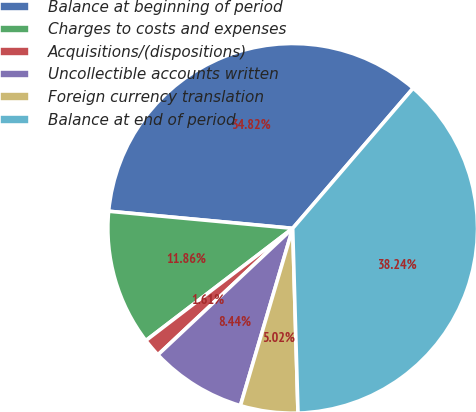Convert chart to OTSL. <chart><loc_0><loc_0><loc_500><loc_500><pie_chart><fcel>Balance at beginning of period<fcel>Charges to costs and expenses<fcel>Acquisitions/(dispositions)<fcel>Uncollectible accounts written<fcel>Foreign currency translation<fcel>Balance at end of period<nl><fcel>34.82%<fcel>11.86%<fcel>1.61%<fcel>8.44%<fcel>5.02%<fcel>38.24%<nl></chart> 